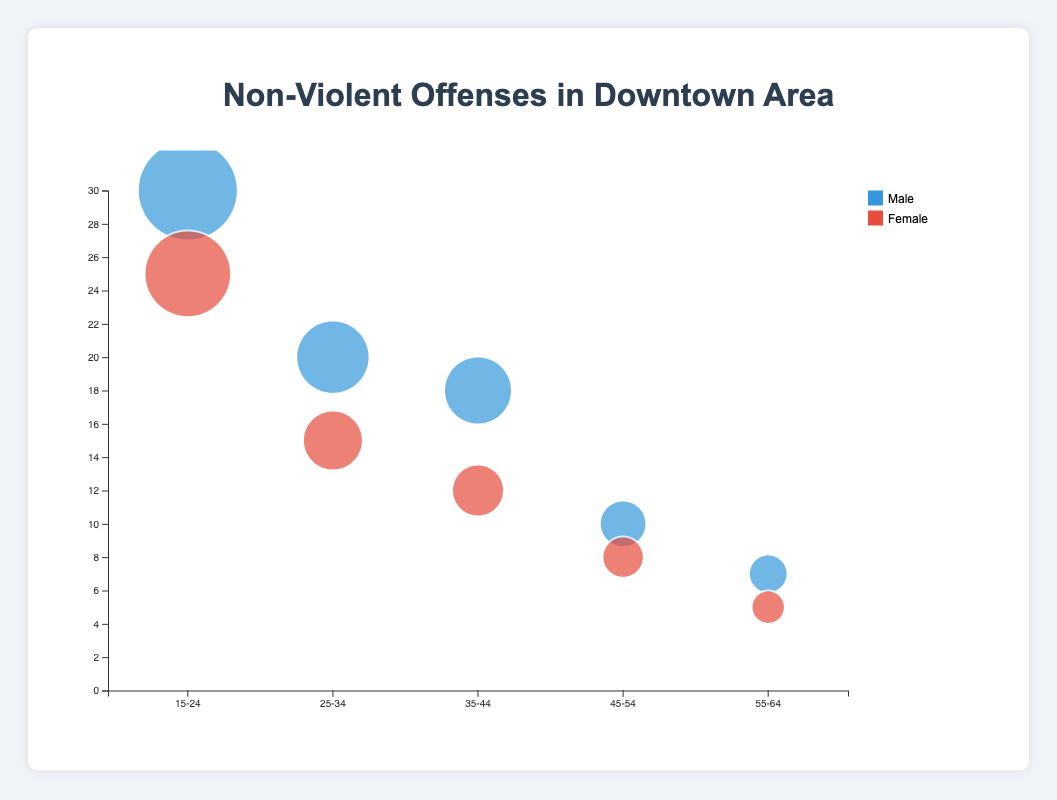What gender has the highest number of Petty Theft incidents in the 15-24 age group? Look at the bubbles for the 15-24 age group and compare the sizes for Male and Female in the Petty Theft category. The male bubble is slightly larger.
Answer: Male Which age group has the lowest number of non-violent offenses recorded? Identify the smallest bubble in the chart. The smallest bubble belongs to the 55-64 age group for females with Disorderly Conduct incidents.
Answer: 55-64 Compare the number of vandalism incidents between males and females in the 25-34 age group. Look at the bubbles for the 25-34 age group. Note the sizes of the bubbles for Vandalism incidents for both Male and Female. There are 20 incidents for males and 15 for females.
Answer: Males have more incidents What is the total number of public intoxication incidents in the 35-44 age group? Sum the number of incidents for both genders in the 35-44 age group for Public Intoxication. The male incidents are 18 and female incidents are 12, so 18 + 12 = 30.
Answer: 30 Which offense type has the most incidents in the 25-34 age group? Compare the sizes of the bubbles in the 25-34 age group for all offense types. Petty Theft, Vandalism, and Public Intoxication all fit this category but we see only Vandalism is present with a total of 35 incidents (20 male, 15 female).
Answer: Vandalism What is the difference in the number of loitering incidents between males and females in the 45-54 age group? Subtract the number of Loitering incidents for females from that of the males in the 45-54 age group. Males have 10 incidents while females have 8, so 10 - 8 = 2.
Answer: 2 In which age group do males have double the incidents compared to females? Compare the number of incidents for males and females in each age group. For Disorderly Conduct in the 55-64 age group, males have 7 incidents and females have 5, which is slightly more than double. No exact double value exists.
Answer: None Which gender is associated with a larger bubble for Public Intoxication in the 35-44 age group? Look specifically at the 35-44 age group and compare the bubbles for Public Intoxication. The male bubble is larger.
Answer: Male By how much do Petty Theft incidents in the 15-24 age group differ between males and females? Subtract the number of Petty Theft incidents for females from males in the 15-24 age group. Males have 30 incidents, and females have 25. Therefore, 30 - 25 = 5.
Answer: 5 